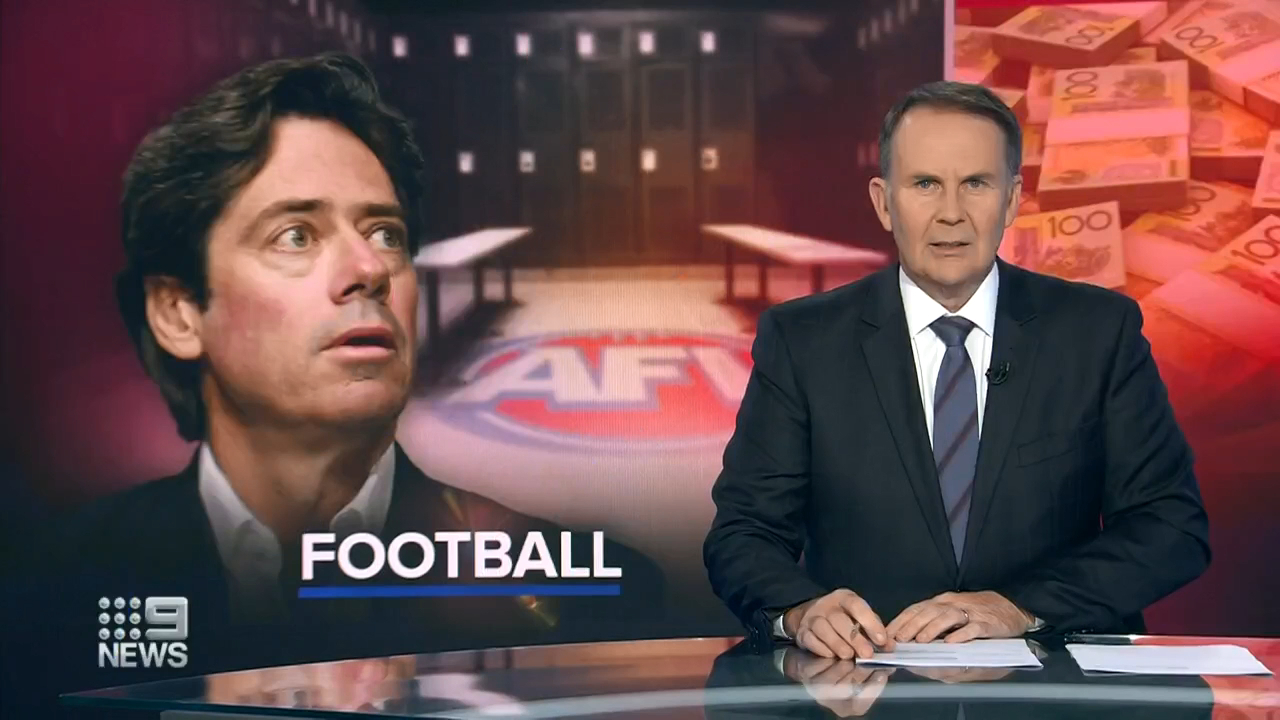How might the financial concerns in the image impact the Australian Football scene? Financial concerns in Australian Football could have wide-reaching impacts. Funding cuts could lead to reduced support for teams, affecting player salaries, training facilities, and overall team performance. This, in turn, could lead to a decrease in fan engagement and ticket sales. The integrity of the sport might also be questioned if there are allegations of corruption or financial misconduct, spreading unease among players, stakeholders, and fans. Continuous financial issues could even lead to the collapse of smaller teams and hinder the development of future talent. 